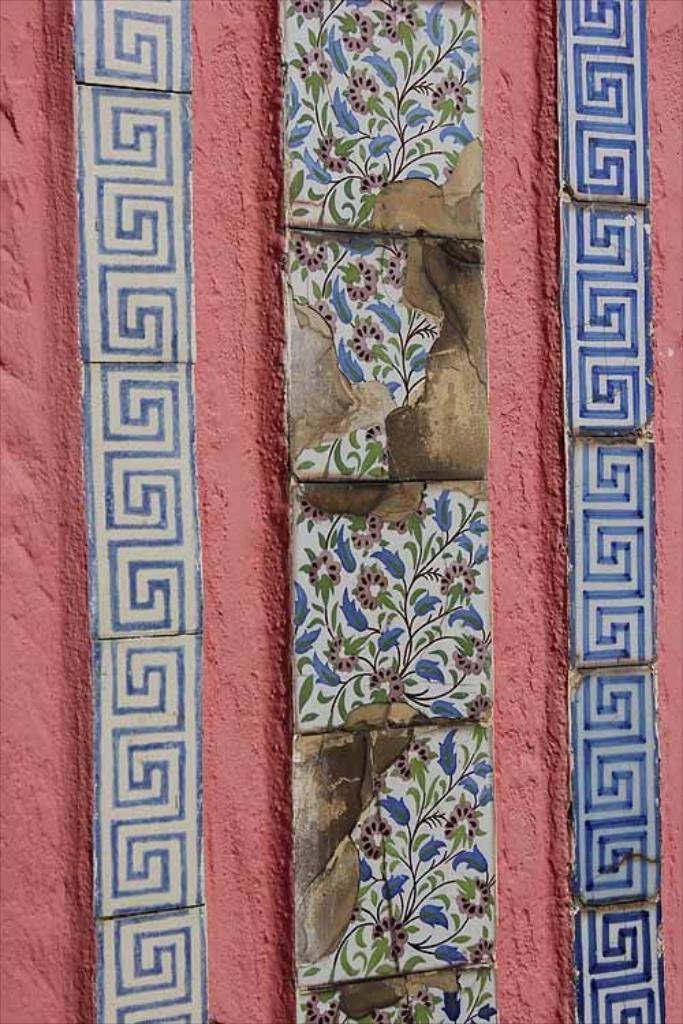What is present on the wall in the image? There is a wall in the image, and there are different types of tiles attached to the wall. What type of approval is required for the tiles on the wall in the image? There is no indication in the image that any specific approval is required for the tiles on the wall. How many rings are hanging from the tiles on the wall in the image? There are no rings visible on the tiles on the wall in the image. 